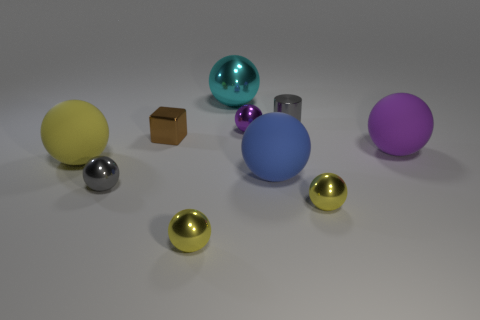Does the small purple sphere have the same material as the cyan sphere?
Ensure brevity in your answer.  Yes. Are there any red metallic balls that have the same size as the gray shiny cylinder?
Give a very brief answer. No. What material is the gray cylinder that is the same size as the gray metal ball?
Your answer should be very brief. Metal. Is there a gray rubber thing of the same shape as the purple matte object?
Give a very brief answer. No. What is the material of the tiny thing that is the same color as the small cylinder?
Ensure brevity in your answer.  Metal. What is the shape of the gray metallic object to the right of the large metal sphere?
Ensure brevity in your answer.  Cylinder. What number of rubber objects are there?
Provide a short and direct response. 3. There is a big ball that is the same material as the tiny cylinder; what is its color?
Make the answer very short. Cyan. What number of small objects are either green metal cylinders or rubber balls?
Keep it short and to the point. 0. What number of yellow spheres are left of the small gray metallic ball?
Provide a succinct answer. 1. 